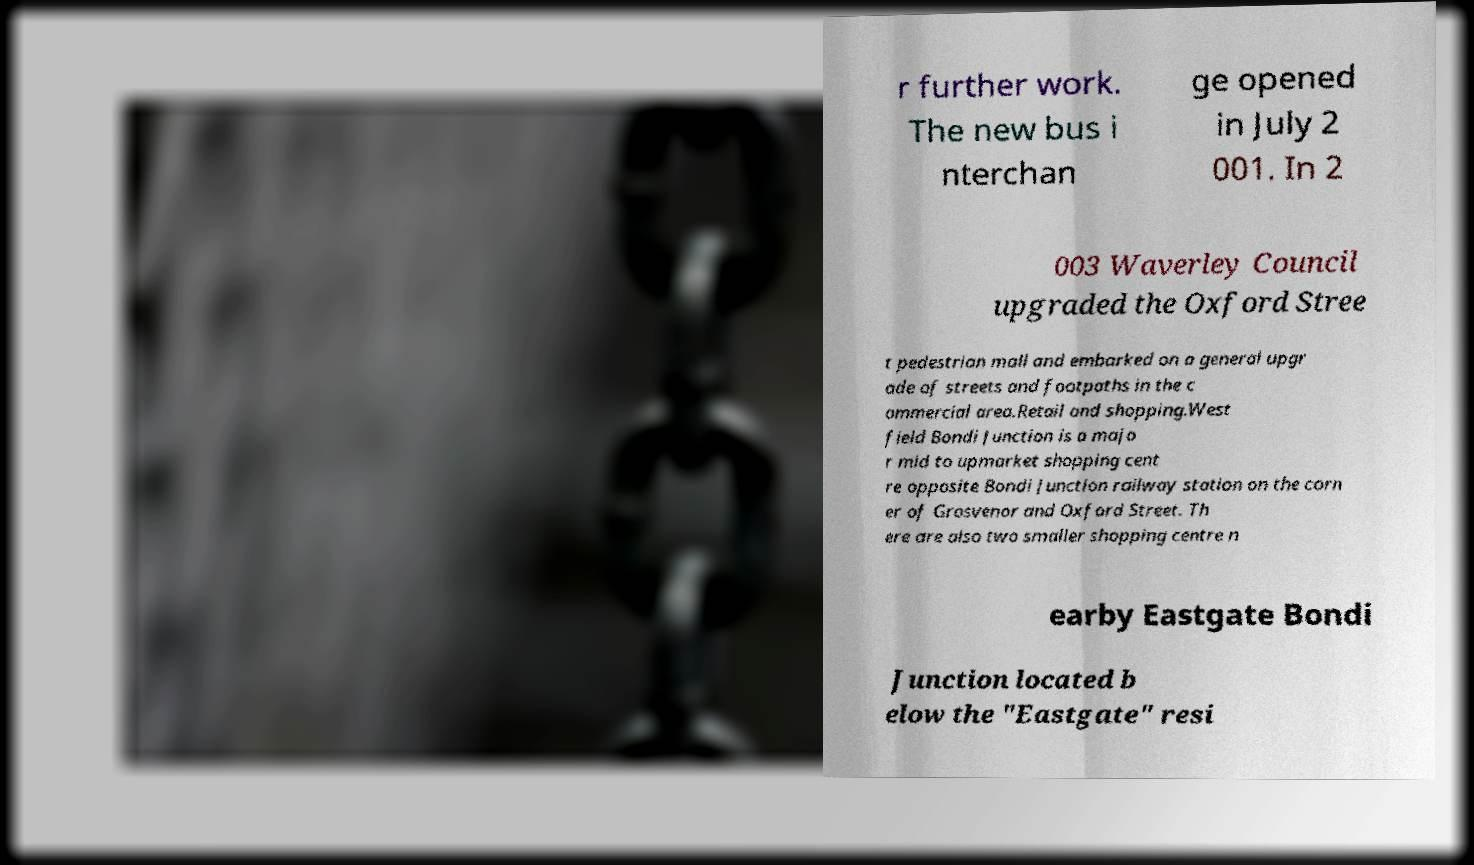Can you read and provide the text displayed in the image?This photo seems to have some interesting text. Can you extract and type it out for me? r further work. The new bus i nterchan ge opened in July 2 001. In 2 003 Waverley Council upgraded the Oxford Stree t pedestrian mall and embarked on a general upgr ade of streets and footpaths in the c ommercial area.Retail and shopping.West field Bondi Junction is a majo r mid to upmarket shopping cent re opposite Bondi Junction railway station on the corn er of Grosvenor and Oxford Street. Th ere are also two smaller shopping centre n earby Eastgate Bondi Junction located b elow the "Eastgate" resi 